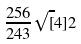Convert formula to latex. <formula><loc_0><loc_0><loc_500><loc_500>\frac { 2 5 6 } { 2 4 3 } \sqrt { [ } 4 ] { 2 }</formula> 